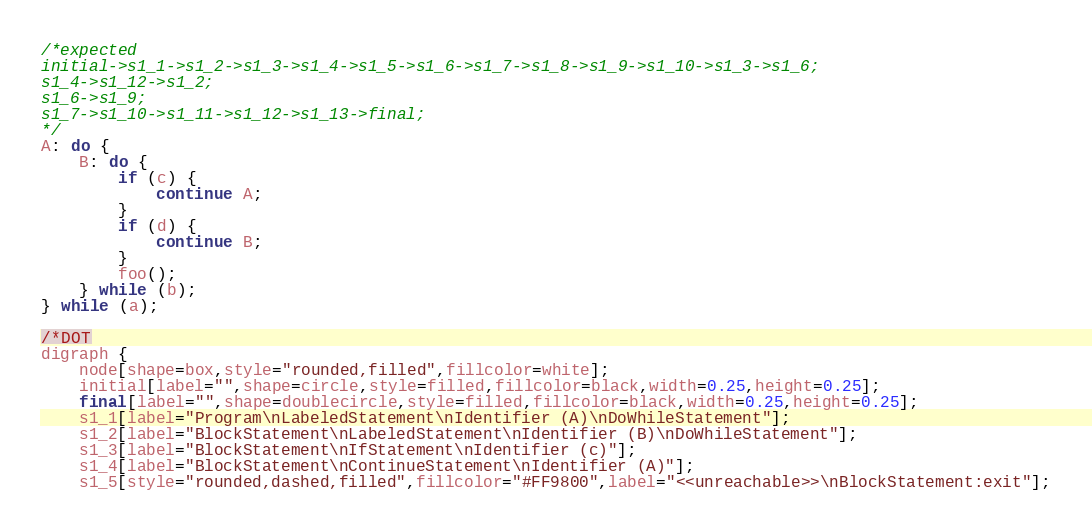Convert code to text. <code><loc_0><loc_0><loc_500><loc_500><_JavaScript_>/*expected
initial->s1_1->s1_2->s1_3->s1_4->s1_5->s1_6->s1_7->s1_8->s1_9->s1_10->s1_3->s1_6;
s1_4->s1_12->s1_2;
s1_6->s1_9;
s1_7->s1_10->s1_11->s1_12->s1_13->final;
*/
A: do {
    B: do {
        if (c) {
            continue A;
        }
        if (d) {
            continue B;
        }
        foo();
    } while (b);
} while (a);

/*DOT
digraph {
    node[shape=box,style="rounded,filled",fillcolor=white];
    initial[label="",shape=circle,style=filled,fillcolor=black,width=0.25,height=0.25];
    final[label="",shape=doublecircle,style=filled,fillcolor=black,width=0.25,height=0.25];
    s1_1[label="Program\nLabeledStatement\nIdentifier (A)\nDoWhileStatement"];
    s1_2[label="BlockStatement\nLabeledStatement\nIdentifier (B)\nDoWhileStatement"];
    s1_3[label="BlockStatement\nIfStatement\nIdentifier (c)"];
    s1_4[label="BlockStatement\nContinueStatement\nIdentifier (A)"];
    s1_5[style="rounded,dashed,filled",fillcolor="#FF9800",label="<<unreachable>>\nBlockStatement:exit"];</code> 